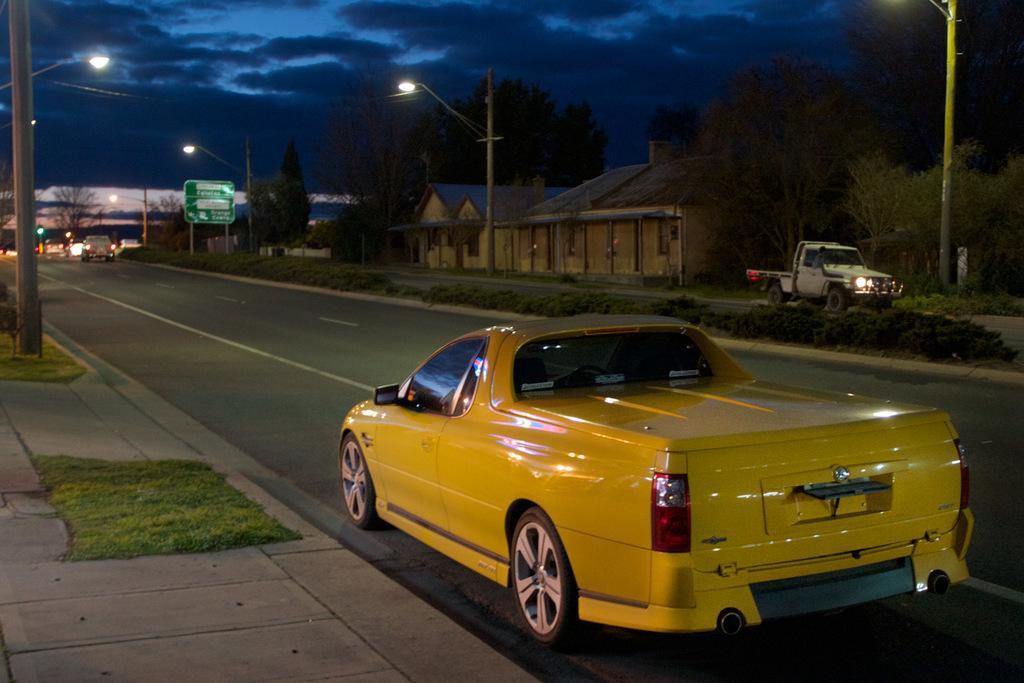Could you give a brief overview of what you see in this image? In this image there is a car on the road, on the other side of the road there is another car passing, in the background of the image there are trees and houses and there are signal boards and lamp posts. 